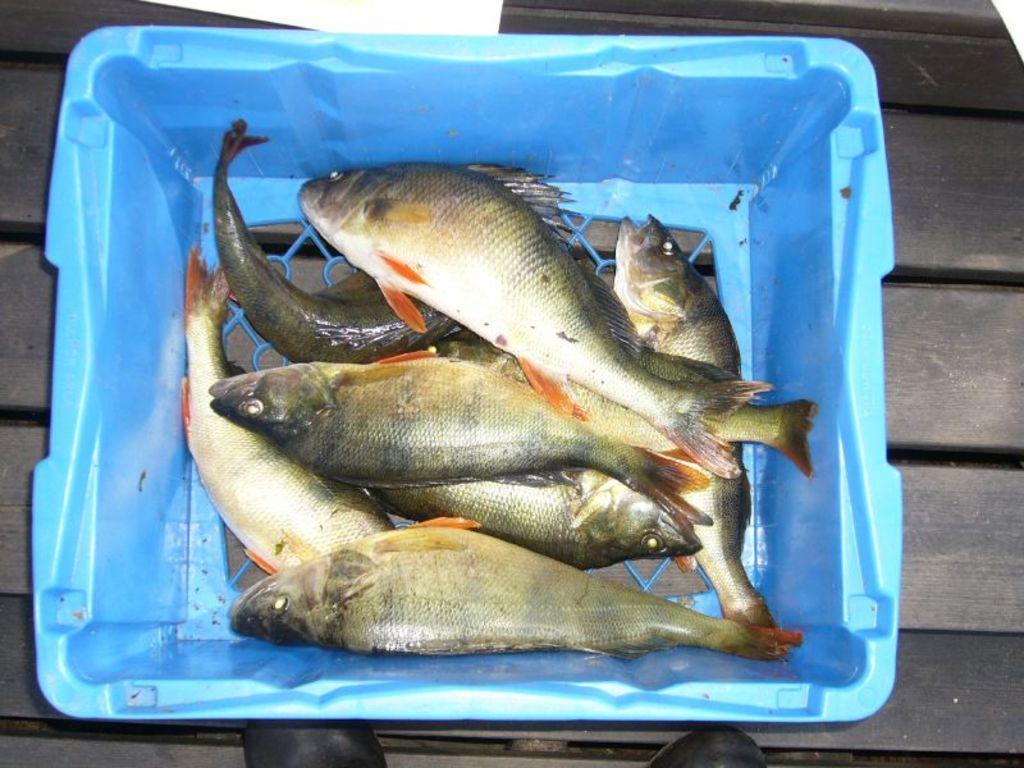Could you give a brief overview of what you see in this image? In the foreground of this picture, there are fishes in a blue basket placed on a black surface and we can also see shoes on the bottom side of the image. 